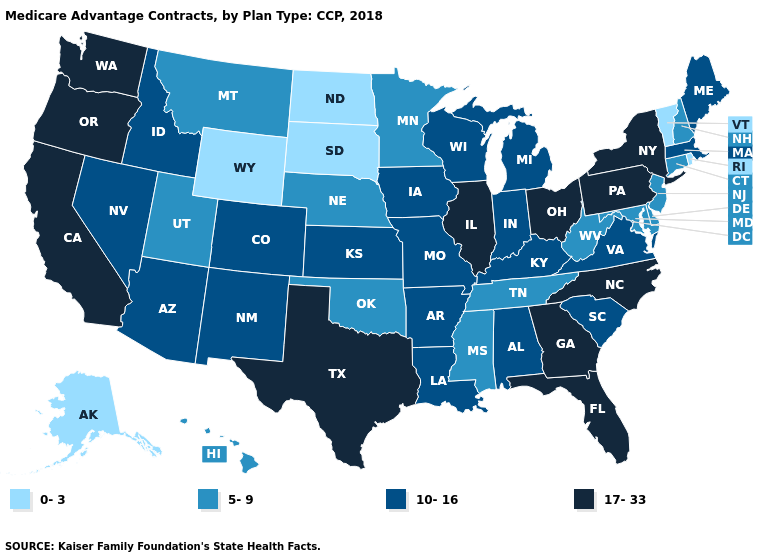What is the value of Nevada?
Short answer required. 10-16. Name the states that have a value in the range 17-33?
Concise answer only. California, Florida, Georgia, Illinois, North Carolina, New York, Ohio, Oregon, Pennsylvania, Texas, Washington. Does Alaska have the lowest value in the West?
Write a very short answer. Yes. Does the map have missing data?
Keep it brief. No. Name the states that have a value in the range 0-3?
Keep it brief. Alaska, North Dakota, Rhode Island, South Dakota, Vermont, Wyoming. Is the legend a continuous bar?
Give a very brief answer. No. What is the lowest value in states that border Minnesota?
Answer briefly. 0-3. Among the states that border Pennsylvania , which have the highest value?
Answer briefly. New York, Ohio. Does Idaho have a higher value than Alaska?
Short answer required. Yes. What is the value of Alabama?
Answer briefly. 10-16. What is the value of Nevada?
Answer briefly. 10-16. Which states have the highest value in the USA?
Answer briefly. California, Florida, Georgia, Illinois, North Carolina, New York, Ohio, Oregon, Pennsylvania, Texas, Washington. What is the value of Washington?
Quick response, please. 17-33. Does the first symbol in the legend represent the smallest category?
Concise answer only. Yes. What is the lowest value in the USA?
Write a very short answer. 0-3. 